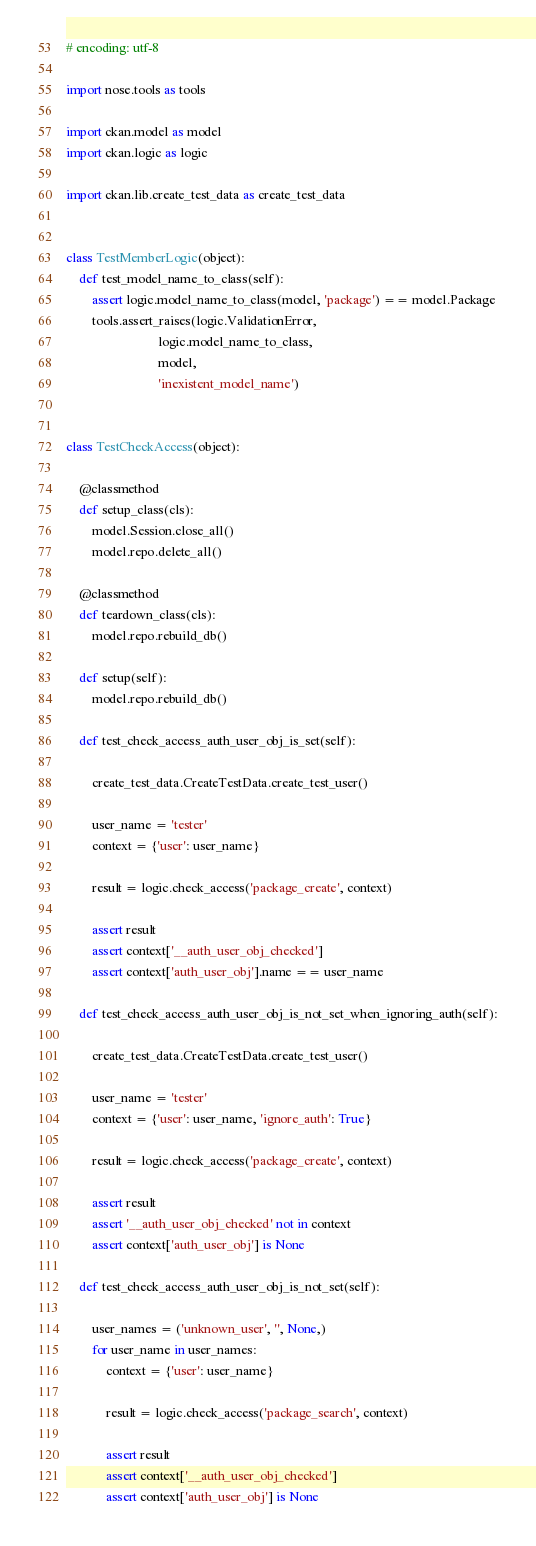<code> <loc_0><loc_0><loc_500><loc_500><_Python_># encoding: utf-8

import nose.tools as tools

import ckan.model as model
import ckan.logic as logic

import ckan.lib.create_test_data as create_test_data


class TestMemberLogic(object):
    def test_model_name_to_class(self):
        assert logic.model_name_to_class(model, 'package') == model.Package
        tools.assert_raises(logic.ValidationError,
                            logic.model_name_to_class,
                            model,
                            'inexistent_model_name')


class TestCheckAccess(object):

    @classmethod
    def setup_class(cls):
        model.Session.close_all()
        model.repo.delete_all()

    @classmethod
    def teardown_class(cls):
        model.repo.rebuild_db()

    def setup(self):
        model.repo.rebuild_db()

    def test_check_access_auth_user_obj_is_set(self):

        create_test_data.CreateTestData.create_test_user()

        user_name = 'tester'
        context = {'user': user_name}

        result = logic.check_access('package_create', context)

        assert result
        assert context['__auth_user_obj_checked']
        assert context['auth_user_obj'].name == user_name

    def test_check_access_auth_user_obj_is_not_set_when_ignoring_auth(self):

        create_test_data.CreateTestData.create_test_user()

        user_name = 'tester'
        context = {'user': user_name, 'ignore_auth': True}

        result = logic.check_access('package_create', context)

        assert result
        assert '__auth_user_obj_checked' not in context
        assert context['auth_user_obj'] is None

    def test_check_access_auth_user_obj_is_not_set(self):

        user_names = ('unknown_user', '', None,)
        for user_name in user_names:
            context = {'user': user_name}

            result = logic.check_access('package_search', context)

            assert result
            assert context['__auth_user_obj_checked']
            assert context['auth_user_obj'] is None
</code> 